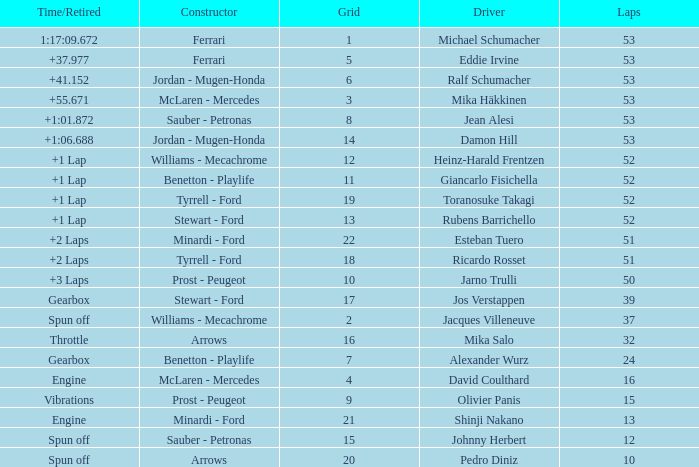Who built the car that went 53 laps with a Time/Retired of 1:17:09.672? Ferrari. 